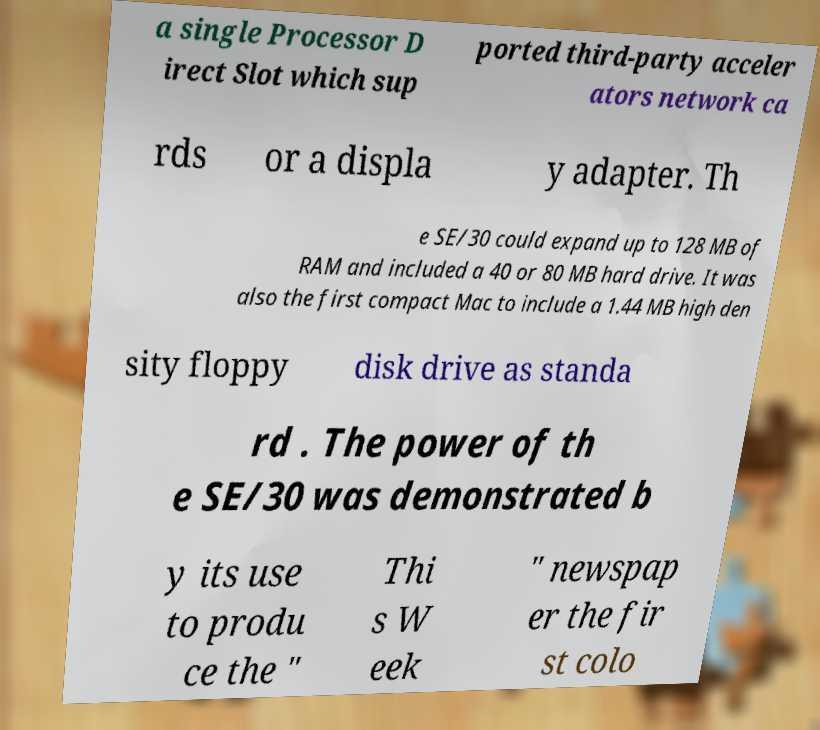Please identify and transcribe the text found in this image. a single Processor D irect Slot which sup ported third-party acceler ators network ca rds or a displa y adapter. Th e SE/30 could expand up to 128 MB of RAM and included a 40 or 80 MB hard drive. It was also the first compact Mac to include a 1.44 MB high den sity floppy disk drive as standa rd . The power of th e SE/30 was demonstrated b y its use to produ ce the " Thi s W eek " newspap er the fir st colo 